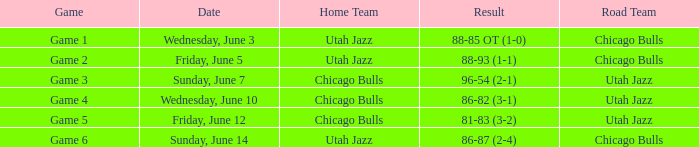Game of game 5 had what result? 81-83 (3-2). 